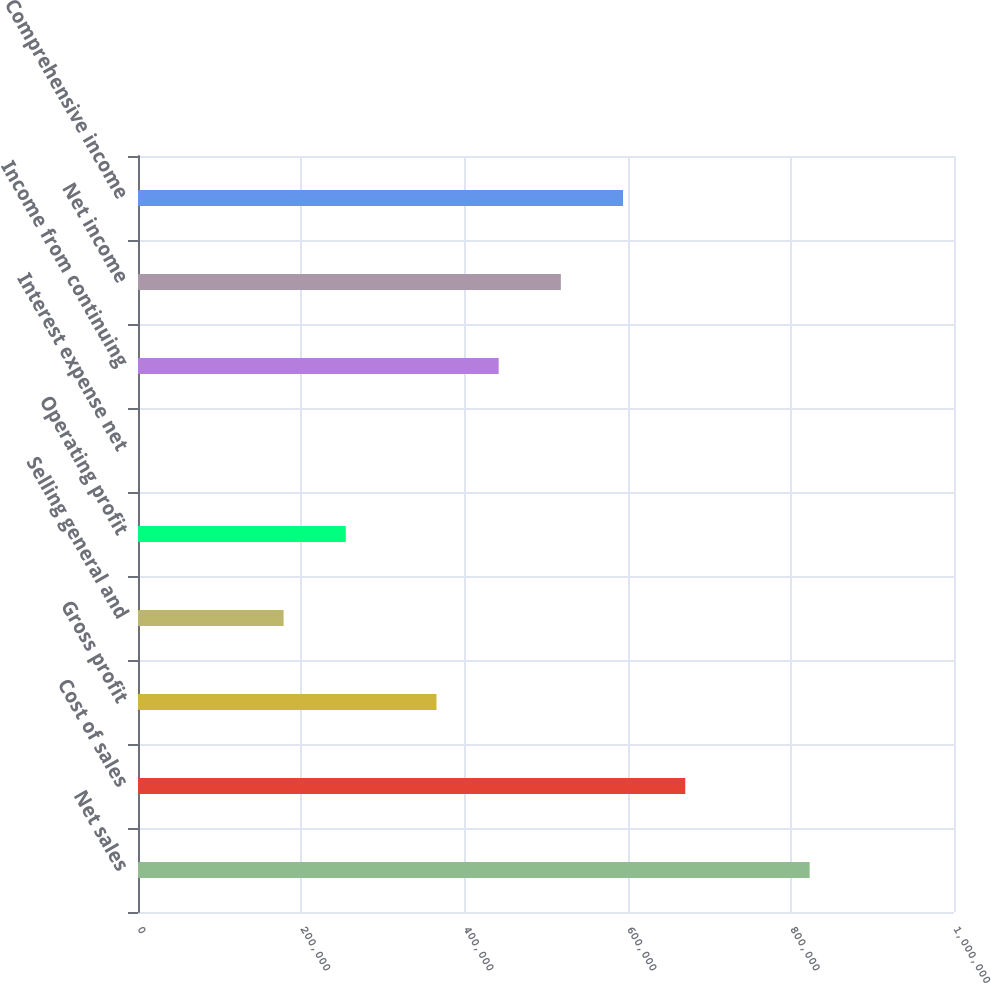Convert chart to OTSL. <chart><loc_0><loc_0><loc_500><loc_500><bar_chart><fcel>Net sales<fcel>Cost of sales<fcel>Gross profit<fcel>Selling general and<fcel>Operating profit<fcel>Interest expense net<fcel>Income from continuing<fcel>Net income<fcel>Comprehensive income<nl><fcel>823110<fcel>670663<fcel>365768<fcel>178434<fcel>254658<fcel>20<fcel>441992<fcel>518215<fcel>594439<nl></chart> 